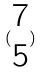<formula> <loc_0><loc_0><loc_500><loc_500>( \begin{matrix} 7 \\ 5 \end{matrix} )</formula> 